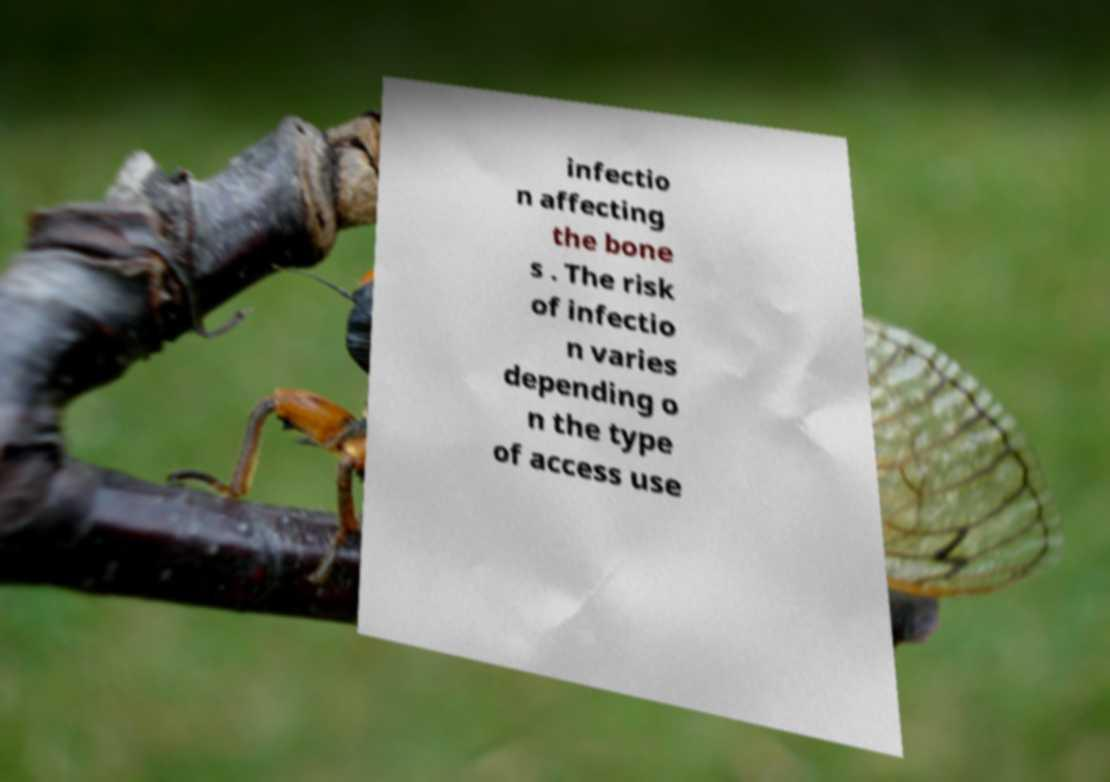I need the written content from this picture converted into text. Can you do that? infectio n affecting the bone s . The risk of infectio n varies depending o n the type of access use 